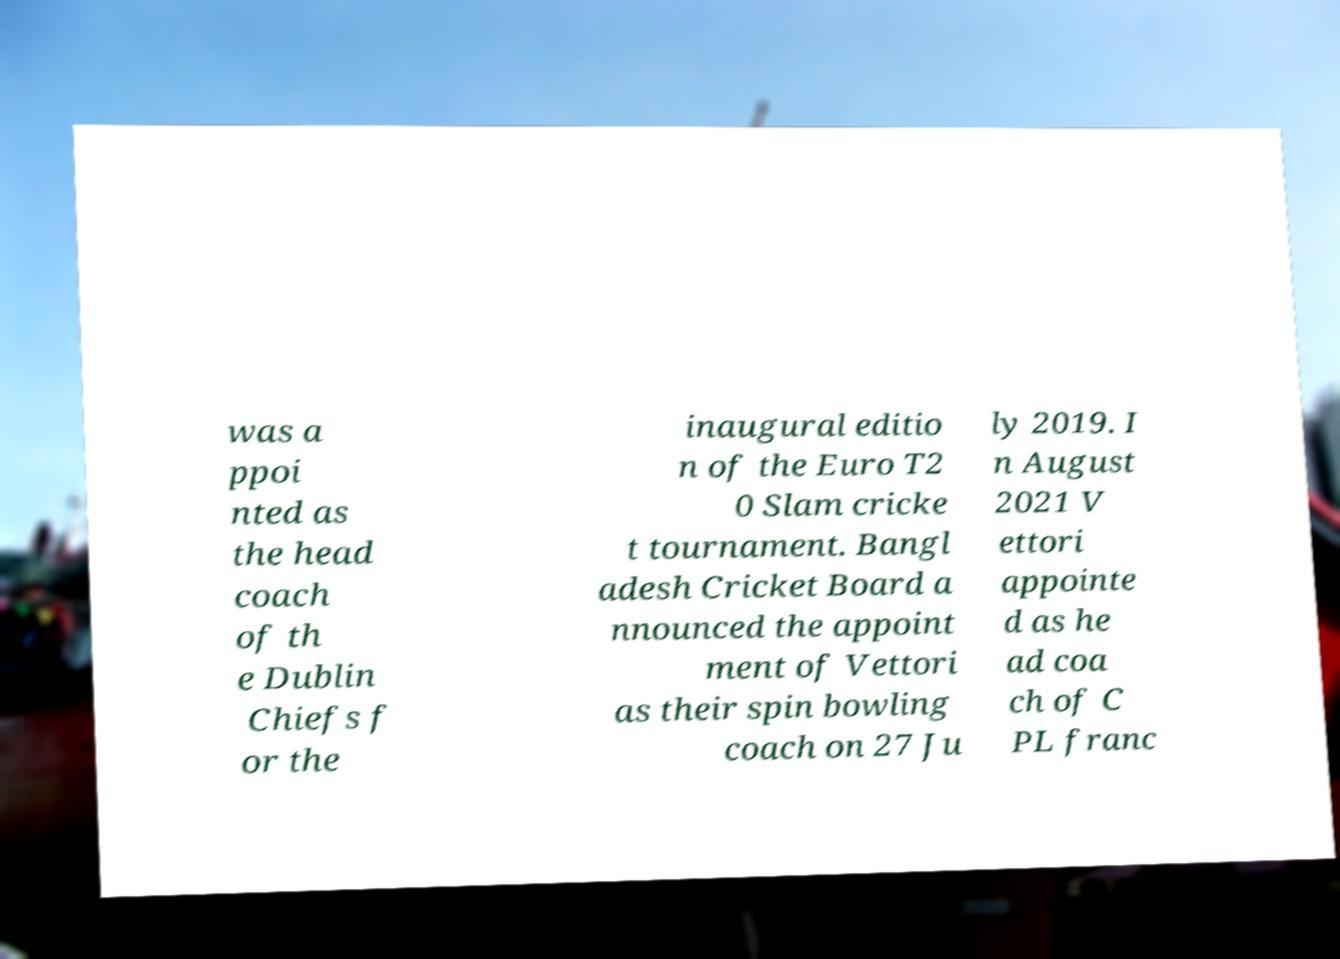Please identify and transcribe the text found in this image. was a ppoi nted as the head coach of th e Dublin Chiefs f or the inaugural editio n of the Euro T2 0 Slam cricke t tournament. Bangl adesh Cricket Board a nnounced the appoint ment of Vettori as their spin bowling coach on 27 Ju ly 2019. I n August 2021 V ettori appointe d as he ad coa ch of C PL franc 